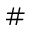Convert formula to latex. <formula><loc_0><loc_0><loc_500><loc_500>\#</formula> 